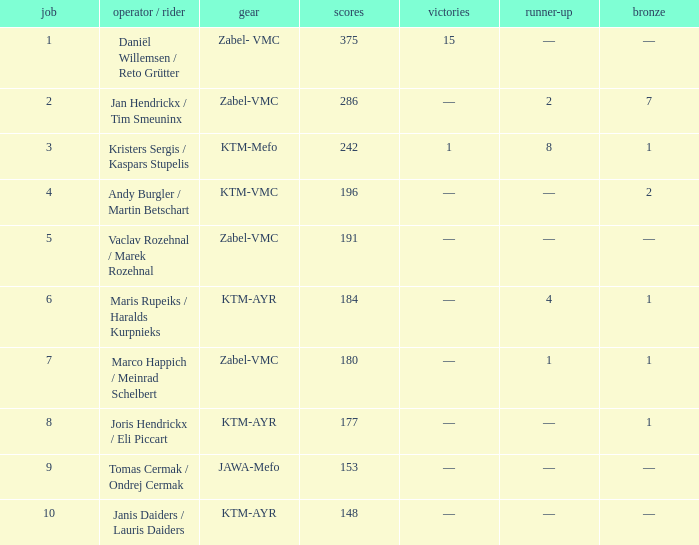Who was the driver/passengar when the position was smaller than 8, the third was 1, and there was 1 win? Kristers Sergis / Kaspars Stupelis. 